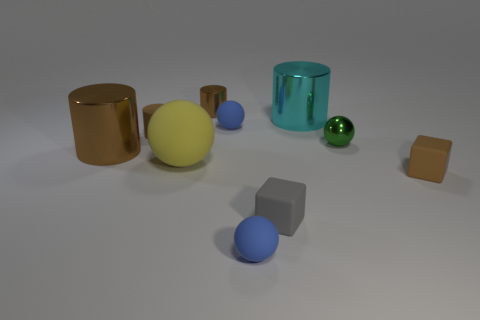How many other objects are the same material as the tiny gray object?
Make the answer very short. 5. What shape is the tiny brown rubber object that is in front of the green metallic thing right of the yellow sphere?
Your answer should be compact. Cube. What is the size of the blue thing behind the small green object?
Your answer should be very brief. Small. Is the material of the tiny gray thing the same as the yellow thing?
Your response must be concise. Yes. What is the shape of the large object that is made of the same material as the cyan cylinder?
Provide a short and direct response. Cylinder. Are there any other things of the same color as the large rubber ball?
Ensure brevity in your answer.  No. There is a small metal object to the left of the small gray thing; what color is it?
Give a very brief answer. Brown. There is a tiny sphere in front of the big matte sphere; does it have the same color as the large rubber sphere?
Make the answer very short. No. There is a large brown object that is the same shape as the cyan object; what is it made of?
Give a very brief answer. Metal. How many yellow matte spheres have the same size as the cyan shiny object?
Give a very brief answer. 1. 